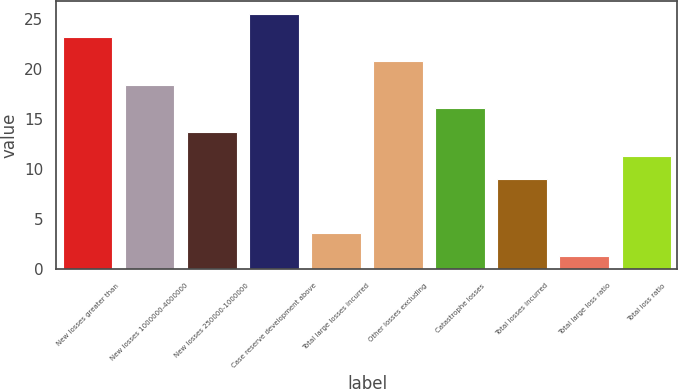Convert chart to OTSL. <chart><loc_0><loc_0><loc_500><loc_500><bar_chart><fcel>New losses greater than<fcel>New losses 1000000-4000000<fcel>New losses 250000-1000000<fcel>Case reserve development above<fcel>Total large losses incurred<fcel>Other losses excluding<fcel>Catastrophe losses<fcel>Total losses incurred<fcel>Total large loss ratio<fcel>Total loss ratio<nl><fcel>23.22<fcel>18.48<fcel>13.74<fcel>25.59<fcel>3.67<fcel>20.85<fcel>16.11<fcel>9<fcel>1.3<fcel>11.37<nl></chart> 